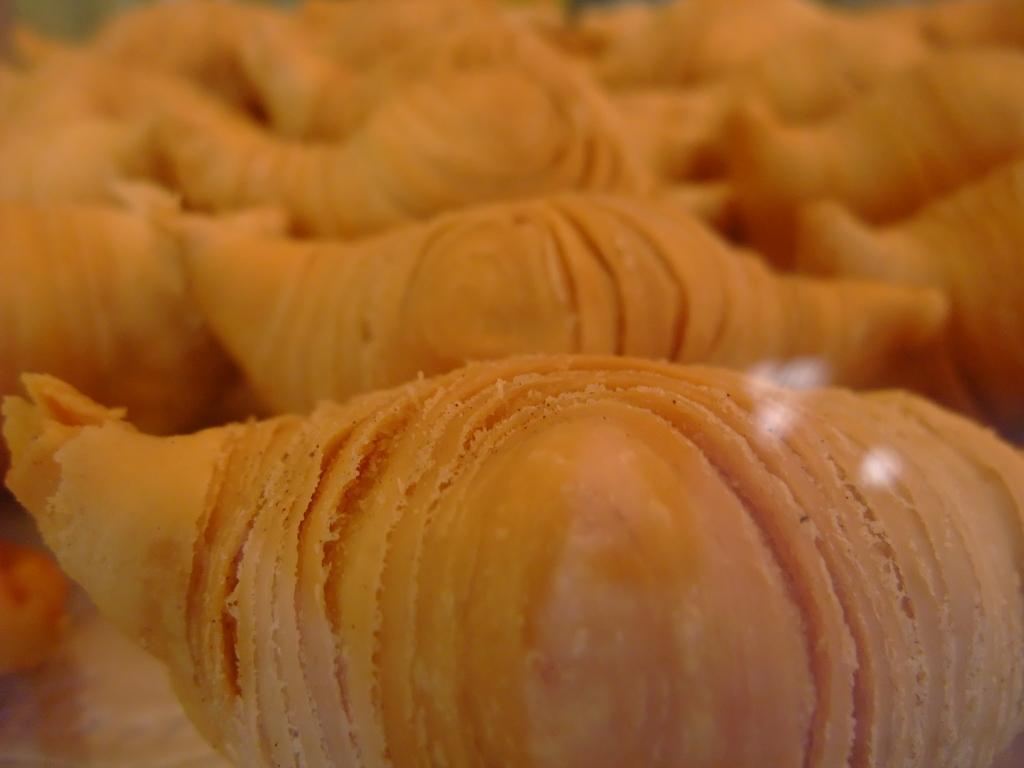Describe this image in one or two sentences. In this image at front we can see a sweet bread on the table. 